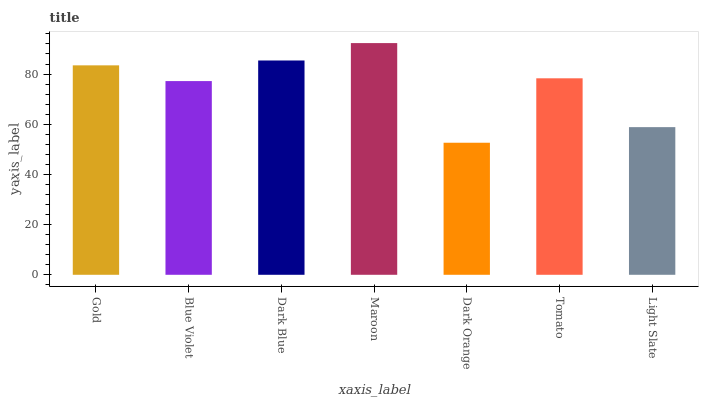Is Dark Orange the minimum?
Answer yes or no. Yes. Is Maroon the maximum?
Answer yes or no. Yes. Is Blue Violet the minimum?
Answer yes or no. No. Is Blue Violet the maximum?
Answer yes or no. No. Is Gold greater than Blue Violet?
Answer yes or no. Yes. Is Blue Violet less than Gold?
Answer yes or no. Yes. Is Blue Violet greater than Gold?
Answer yes or no. No. Is Gold less than Blue Violet?
Answer yes or no. No. Is Tomato the high median?
Answer yes or no. Yes. Is Tomato the low median?
Answer yes or no. Yes. Is Dark Orange the high median?
Answer yes or no. No. Is Blue Violet the low median?
Answer yes or no. No. 